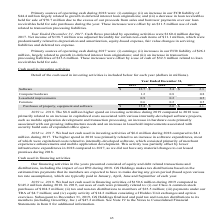From Greensky's financial document, Which years does the table provide information for the cash used in investing activities? The document contains multiple relevant values: 2019, 2018, 2017. From the document: "Year Ended December 31, 2019 2018 2017 Software $ 12.7 $ 5.4 $ 2.3 Computer hardware 1.2 0.8 0.8 Leasehold improvements 0.9 0.2 0.5 Furnit Year Ended ..." Also, What was the cash used in Software in 2019? According to the financial document, 12.7 (in millions). The relevant text states: "Year Ended December 31, 2019 2018 2017 Software $ 12.7 $ 5.4 $ 2.3 Computer hardware 1.2 0.8 0.8 Leasehold improvements 0.9 0.2 0.5 Furniture 0.6 0.2 0.5..." Also, What was the cash used in Computer Hardware in 2017? According to the financial document, 0.8 (in millions). The relevant text states: "Software $ 12.7 $ 5.4 $ 2.3 Computer hardware 1.2 0.8 0.8 Leasehold improvements 0.9 0.2 0.5 Furniture 0.6 0.2 0.5 Purchases of property, equipment and s..." Additionally, Which years did cash used in Furniture exceed $0.3 million? The document shows two values: 2019 and 2017. From the document: "Year Ended December 31, 2019 2018 2017 Software $ 12.7 $ 5.4 $ 2.3 Computer hardware 1.2 0.8 0.8 Leasehold improvements 0.9 0.2 0.5 Furnit Year Ended ..." Also, can you calculate: What was the change in the cash used in Leasehold Improvements between 2017 and 2019? Based on the calculation: 0.9-0.5, the result is 0.4 (in millions). This is based on the information: "puter hardware 1.2 0.8 0.8 Leasehold improvements 0.9 0.2 0.5 Furniture 0.6 0.2 0.5 Purchases of property, equipment and software $ 15.4 $ 6.6 $ 4.1 rdware 1.2 0.8 0.8 Leasehold improvements 0.9 0.2 0..." The key data points involved are: 0.5, 0.9. Also, can you calculate: What was the percentage change in the Purchases of property, equipment and software between 2018 and 2019? To answer this question, I need to perform calculations using the financial data. The calculation is: (15.4-6.6)/6.6, which equals 133.33 (percentage). This is based on the information: "5 Purchases of property, equipment and software $ 15.4 $ 6.6 $ 4.1 ases of property, equipment and software $ 15.4 $ 6.6 $ 4.1..." The key data points involved are: 15.4, 6.6. 